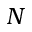Convert formula to latex. <formula><loc_0><loc_0><loc_500><loc_500>N</formula> 